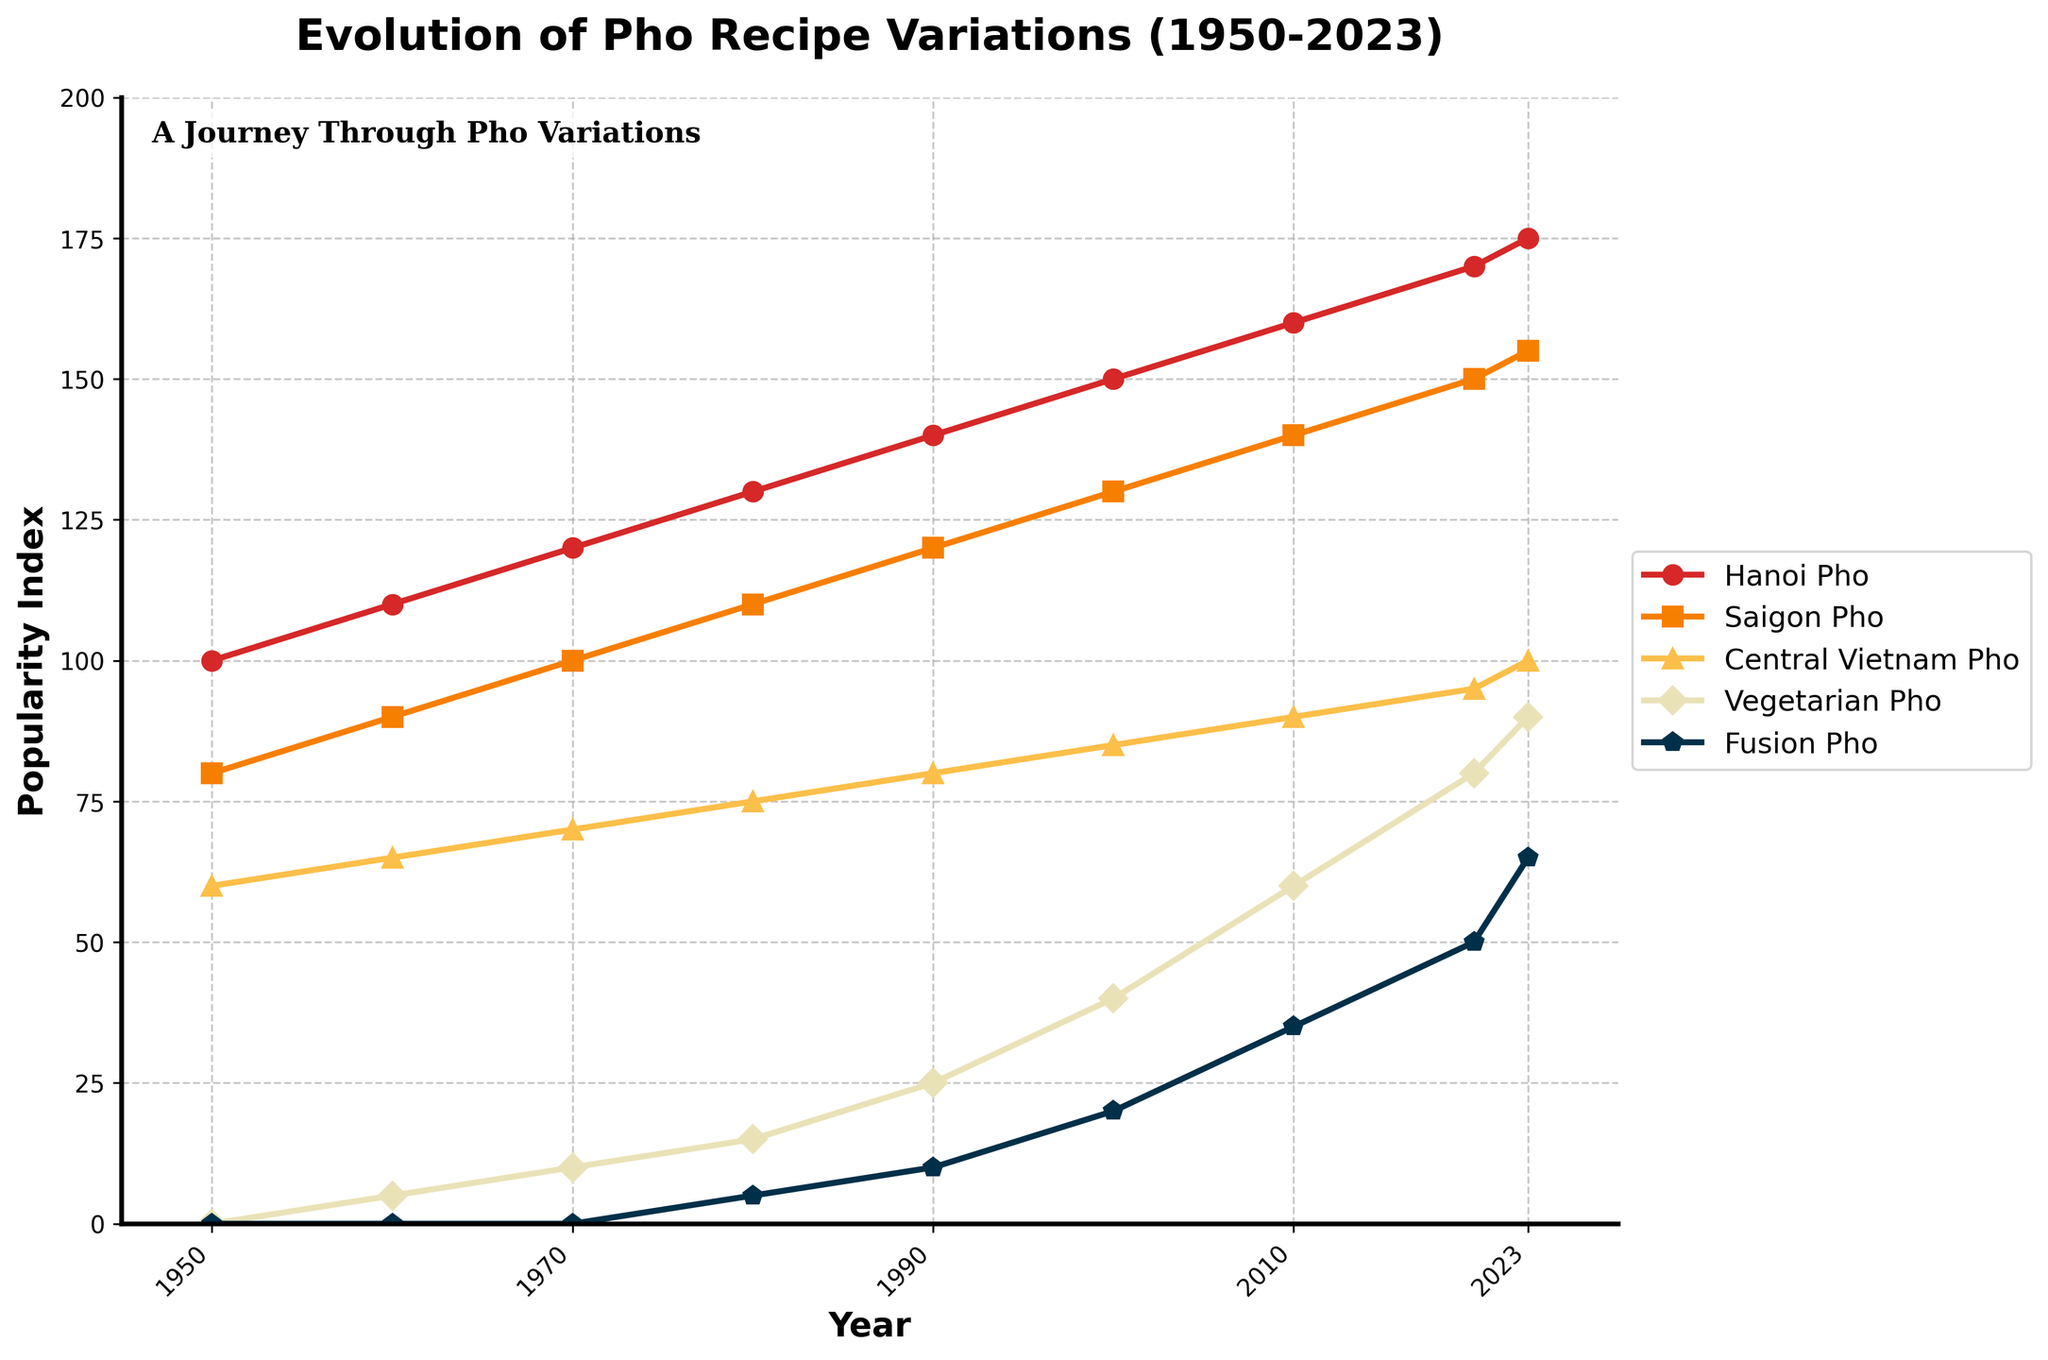Which type of pho had the highest popularity index in 2023? From the plot, identify the lines representing different types of pho for the year 2023. The line with the highest y-value in 2023 corresponds to Hanoi Pho.
Answer: Hanoi Pho Between 1950 and 2023, which type of pho had the most significant increase in popularity index? Calculate the difference in popularity index between 1950 and 2023 for each type of pho. Hanoi Pho increased from 100 to 175 (75), Saigon Pho increased from 80 to 155 (75), Central Vietnam Pho increased from 60 to 100 (40), Vegetarian Pho increased from 0 to 90 (90), and Fusion Pho increased from 0 to 65 (65). Vegetarian Pho has the most significant increase.
Answer: Vegetarian Pho What was the popularity index of Saigon Pho in the year 2000? Locate the point on the Saigon Pho line corresponding to the year 2000. The y-value of this point is the popularity index.
Answer: 130 In which decade did Vegetarian Pho first appear according to the plot? Observe the line representing Vegetarian Pho. It starts at the y-value greater than 0 between 1950 and 1960. Therefore, it first appeared in the 1960s.
Answer: 1960s Compare the popularity of Fusion Pho and Central Vietnam Pho in 2010. Which was more popular? Look at the points for the year 2010 on the lines for Fusion Pho and Central Vietnam Pho. Central Vietnam Pho's y-value is 90, and Fusion Pho's y-value is 35, which means Central Vietnam Pho was more popular.
Answer: Central Vietnam Pho What is the average popularity index of Hanoi Pho over the decades listed in the plot (from 1950 to 2023)? Calculate the average by summing the popularity indices of Hanoi Pho for the years 1950, 1960, 1970, 1980, 1990, 2000, 2010, 2020, and 2023: (100 + 110 + 120 + 130 + 140 + 150 + 160 + 170 + 175) / 9. The sum is 1255, and the average is 1255 / 9 ≈ 139.44.
Answer: 139.44 What is common about the popularity trends of Hanoi Pho and Saigon Pho between 1950 and 2023? From the plot, observe the general trend lines of Hanoi Pho and Saigon Pho. Both lines show a steady increase in popularity from 1950 to 2023.
Answer: Steady increase Which type of pho shows the most significant change in popularity index  between 2010 and 2023? Calculate the change in popularity index between 2010 and 2023 for each type: Hanoi Pho (175 - 160 = 15), Saigon Pho (155 - 140 = 15), Central Vietnam Pho (100 - 90 = 10), Vegetarian Pho (90 - 60 = 30), and Fusion Pho (65 - 50 = 15). Vegetarian Pho has the most significant change.
Answer: Vegetarian Pho 